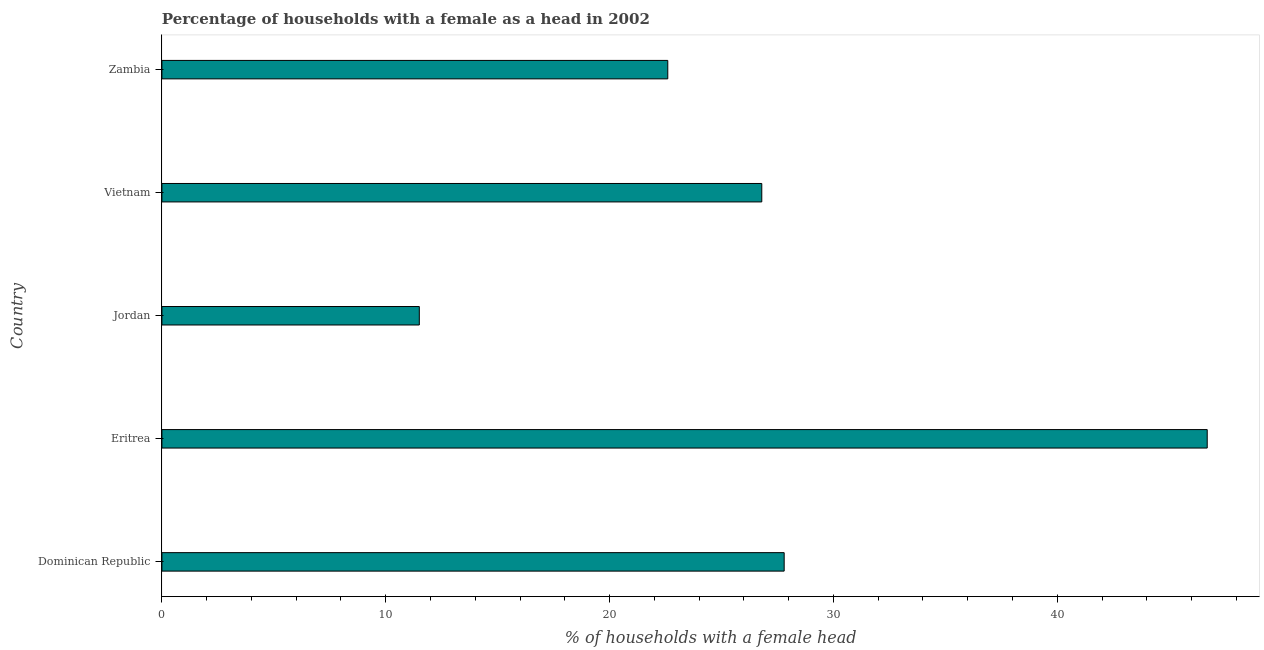Does the graph contain any zero values?
Your answer should be very brief. No. Does the graph contain grids?
Keep it short and to the point. No. What is the title of the graph?
Ensure brevity in your answer.  Percentage of households with a female as a head in 2002. What is the label or title of the X-axis?
Your answer should be compact. % of households with a female head. What is the label or title of the Y-axis?
Give a very brief answer. Country. What is the number of female supervised households in Dominican Republic?
Ensure brevity in your answer.  27.8. Across all countries, what is the maximum number of female supervised households?
Provide a succinct answer. 46.7. In which country was the number of female supervised households maximum?
Your answer should be compact. Eritrea. In which country was the number of female supervised households minimum?
Offer a very short reply. Jordan. What is the sum of the number of female supervised households?
Your answer should be very brief. 135.4. What is the difference between the number of female supervised households in Jordan and Zambia?
Give a very brief answer. -11.1. What is the average number of female supervised households per country?
Give a very brief answer. 27.08. What is the median number of female supervised households?
Give a very brief answer. 26.8. What is the ratio of the number of female supervised households in Dominican Republic to that in Zambia?
Your response must be concise. 1.23. Is the difference between the number of female supervised households in Eritrea and Vietnam greater than the difference between any two countries?
Provide a short and direct response. No. What is the difference between the highest and the second highest number of female supervised households?
Your answer should be very brief. 18.9. What is the difference between the highest and the lowest number of female supervised households?
Offer a very short reply. 35.2. Are all the bars in the graph horizontal?
Your answer should be very brief. Yes. How many countries are there in the graph?
Offer a terse response. 5. What is the difference between two consecutive major ticks on the X-axis?
Provide a succinct answer. 10. What is the % of households with a female head of Dominican Republic?
Your answer should be very brief. 27.8. What is the % of households with a female head in Eritrea?
Ensure brevity in your answer.  46.7. What is the % of households with a female head of Jordan?
Make the answer very short. 11.5. What is the % of households with a female head of Vietnam?
Your response must be concise. 26.8. What is the % of households with a female head in Zambia?
Make the answer very short. 22.6. What is the difference between the % of households with a female head in Dominican Republic and Eritrea?
Offer a very short reply. -18.9. What is the difference between the % of households with a female head in Dominican Republic and Vietnam?
Your answer should be very brief. 1. What is the difference between the % of households with a female head in Eritrea and Jordan?
Provide a short and direct response. 35.2. What is the difference between the % of households with a female head in Eritrea and Vietnam?
Provide a succinct answer. 19.9. What is the difference between the % of households with a female head in Eritrea and Zambia?
Make the answer very short. 24.1. What is the difference between the % of households with a female head in Jordan and Vietnam?
Offer a very short reply. -15.3. What is the difference between the % of households with a female head in Vietnam and Zambia?
Provide a short and direct response. 4.2. What is the ratio of the % of households with a female head in Dominican Republic to that in Eritrea?
Your answer should be very brief. 0.59. What is the ratio of the % of households with a female head in Dominican Republic to that in Jordan?
Give a very brief answer. 2.42. What is the ratio of the % of households with a female head in Dominican Republic to that in Zambia?
Provide a short and direct response. 1.23. What is the ratio of the % of households with a female head in Eritrea to that in Jordan?
Keep it short and to the point. 4.06. What is the ratio of the % of households with a female head in Eritrea to that in Vietnam?
Provide a short and direct response. 1.74. What is the ratio of the % of households with a female head in Eritrea to that in Zambia?
Provide a succinct answer. 2.07. What is the ratio of the % of households with a female head in Jordan to that in Vietnam?
Make the answer very short. 0.43. What is the ratio of the % of households with a female head in Jordan to that in Zambia?
Make the answer very short. 0.51. What is the ratio of the % of households with a female head in Vietnam to that in Zambia?
Provide a short and direct response. 1.19. 